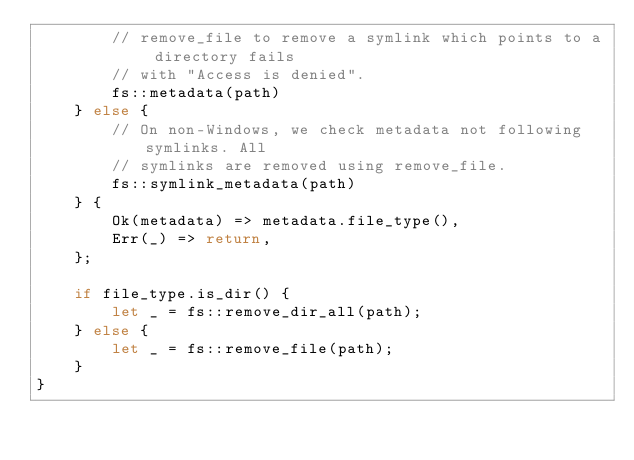<code> <loc_0><loc_0><loc_500><loc_500><_Rust_>        // remove_file to remove a symlink which points to a directory fails
        // with "Access is denied".
        fs::metadata(path)
    } else {
        // On non-Windows, we check metadata not following symlinks. All
        // symlinks are removed using remove_file.
        fs::symlink_metadata(path)
    } {
        Ok(metadata) => metadata.file_type(),
        Err(_) => return,
    };

    if file_type.is_dir() {
        let _ = fs::remove_dir_all(path);
    } else {
        let _ = fs::remove_file(path);
    }
}
</code> 